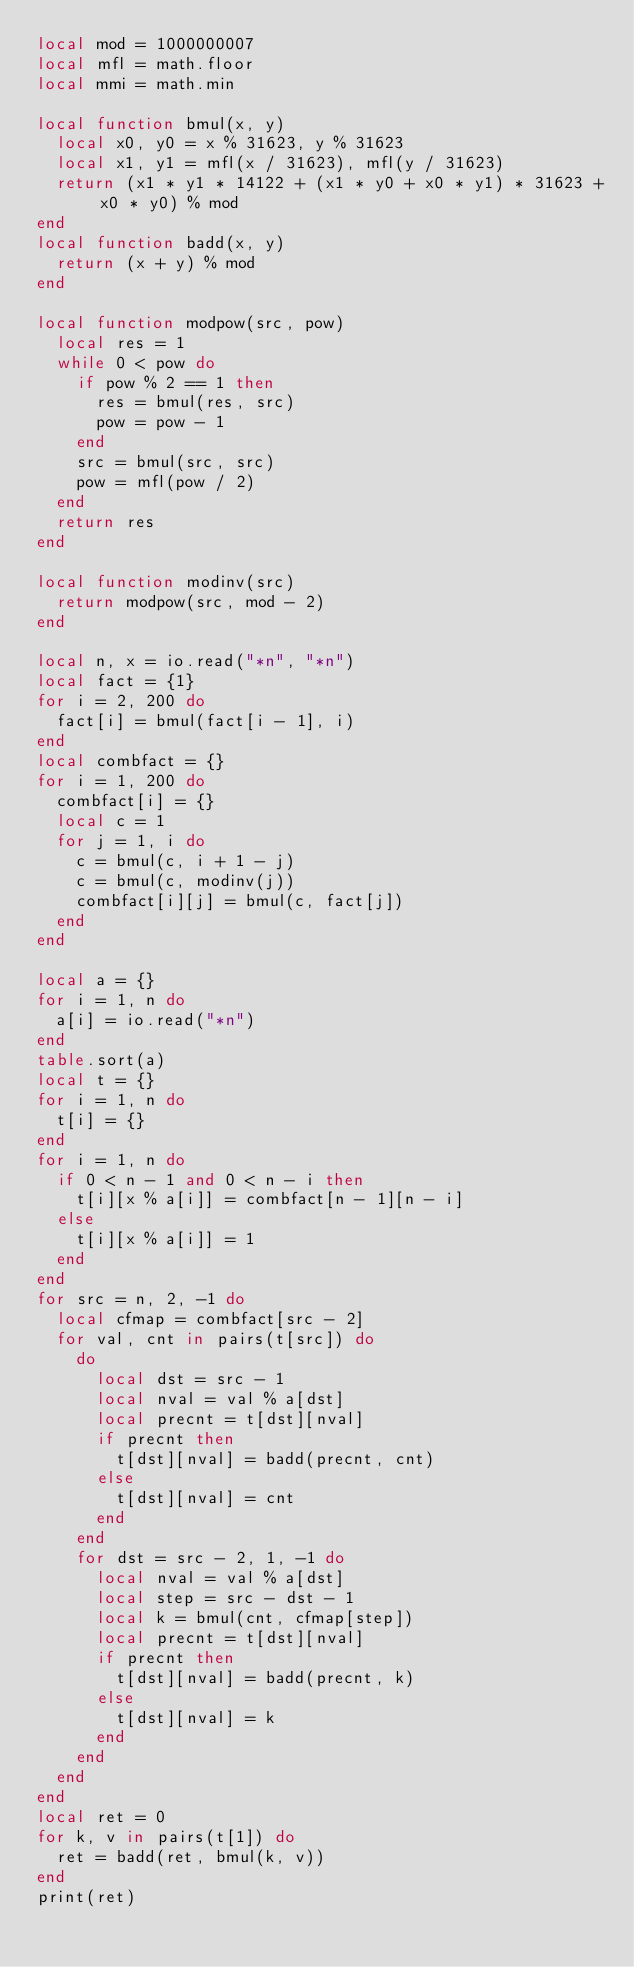<code> <loc_0><loc_0><loc_500><loc_500><_Lua_>local mod = 1000000007
local mfl = math.floor
local mmi = math.min

local function bmul(x, y)
  local x0, y0 = x % 31623, y % 31623
  local x1, y1 = mfl(x / 31623), mfl(y / 31623)
  return (x1 * y1 * 14122 + (x1 * y0 + x0 * y1) * 31623 + x0 * y0) % mod
end
local function badd(x, y)
  return (x + y) % mod
end

local function modpow(src, pow)
  local res = 1
  while 0 < pow do
    if pow % 2 == 1 then
      res = bmul(res, src)
      pow = pow - 1
    end
    src = bmul(src, src)
    pow = mfl(pow / 2)
  end
  return res
end

local function modinv(src)
  return modpow(src, mod - 2)
end

local n, x = io.read("*n", "*n")
local fact = {1}
for i = 2, 200 do
  fact[i] = bmul(fact[i - 1], i)
end
local combfact = {}
for i = 1, 200 do
  combfact[i] = {}
  local c = 1
  for j = 1, i do
    c = bmul(c, i + 1 - j)
    c = bmul(c, modinv(j))
    combfact[i][j] = bmul(c, fact[j])
  end
end

local a = {}
for i = 1, n do
  a[i] = io.read("*n")
end
table.sort(a)
local t = {}
for i = 1, n do
  t[i] = {}
end
for i = 1, n do
  if 0 < n - 1 and 0 < n - i then
    t[i][x % a[i]] = combfact[n - 1][n - i]
  else
    t[i][x % a[i]] = 1
  end
end
for src = n, 2, -1 do
  local cfmap = combfact[src - 2]
  for val, cnt in pairs(t[src]) do
    do
      local dst = src - 1
      local nval = val % a[dst]
      local precnt = t[dst][nval]
      if precnt then
        t[dst][nval] = badd(precnt, cnt)
      else
        t[dst][nval] = cnt
      end
    end
    for dst = src - 2, 1, -1 do
      local nval = val % a[dst]
      local step = src - dst - 1
      local k = bmul(cnt, cfmap[step])
      local precnt = t[dst][nval]
      if precnt then
        t[dst][nval] = badd(precnt, k)
      else
        t[dst][nval] = k
      end
    end
  end
end
local ret = 0
for k, v in pairs(t[1]) do
  ret = badd(ret, bmul(k, v))
end
print(ret)
</code> 